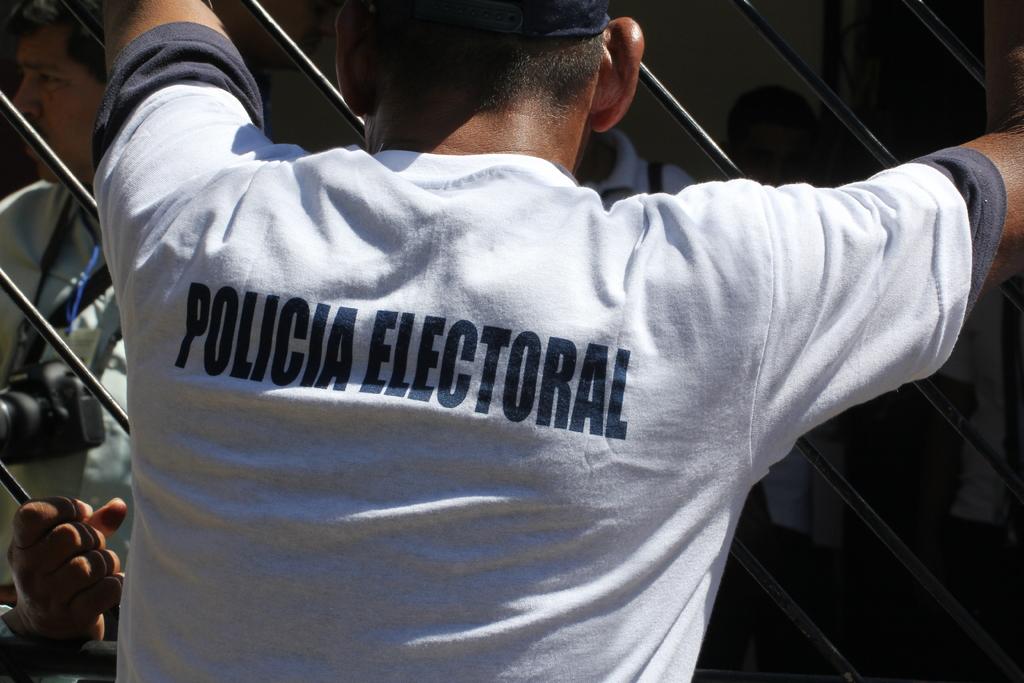What language is this written in?
Make the answer very short. Spanish. What does the shirt say>?
Give a very brief answer. Policia electoral. 